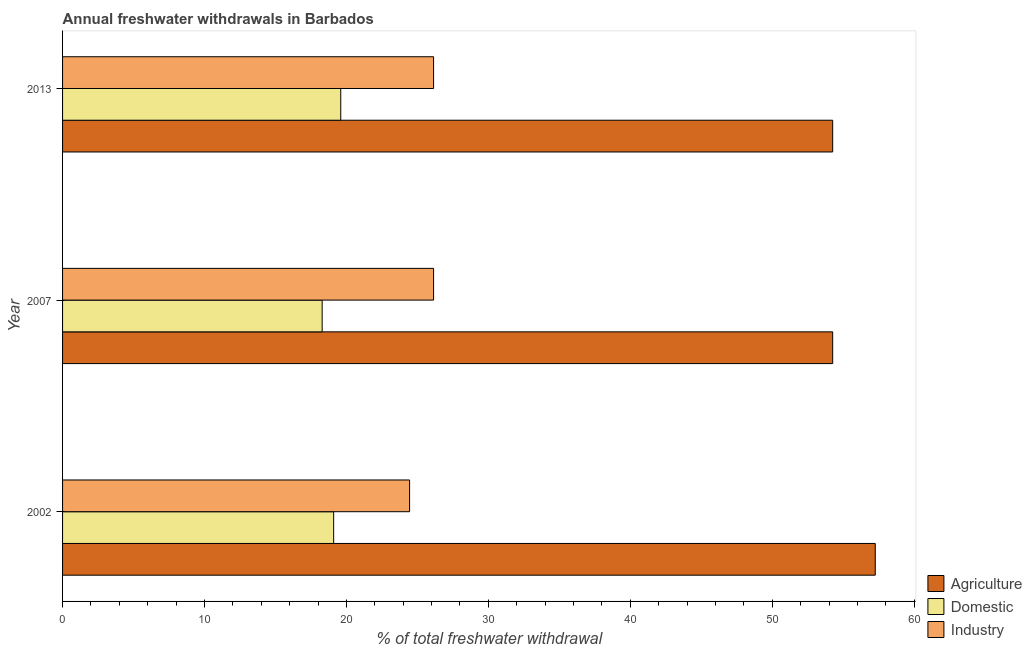How many different coloured bars are there?
Provide a short and direct response. 3. How many groups of bars are there?
Ensure brevity in your answer.  3. Are the number of bars on each tick of the Y-axis equal?
Offer a very short reply. Yes. How many bars are there on the 1st tick from the bottom?
Provide a succinct answer. 3. What is the percentage of freshwater withdrawal for industry in 2002?
Ensure brevity in your answer.  24.45. Across all years, what is the maximum percentage of freshwater withdrawal for domestic purposes?
Your answer should be compact. 19.6. Across all years, what is the minimum percentage of freshwater withdrawal for industry?
Your answer should be compact. 24.45. What is the total percentage of freshwater withdrawal for industry in the graph?
Offer a terse response. 76.73. What is the difference between the percentage of freshwater withdrawal for industry in 2002 and that in 2013?
Make the answer very short. -1.69. What is the difference between the percentage of freshwater withdrawal for domestic purposes in 2007 and the percentage of freshwater withdrawal for industry in 2013?
Provide a succinct answer. -7.85. What is the average percentage of freshwater withdrawal for domestic purposes per year?
Offer a very short reply. 19. In the year 2007, what is the difference between the percentage of freshwater withdrawal for industry and percentage of freshwater withdrawal for agriculture?
Provide a short and direct response. -28.12. In how many years, is the percentage of freshwater withdrawal for agriculture greater than 52 %?
Provide a succinct answer. 3. What is the ratio of the percentage of freshwater withdrawal for industry in 2002 to that in 2007?
Your answer should be very brief. 0.94. Is the percentage of freshwater withdrawal for domestic purposes in 2002 less than that in 2007?
Your answer should be compact. No. What is the difference between the highest and the lowest percentage of freshwater withdrawal for agriculture?
Ensure brevity in your answer.  3. What does the 1st bar from the top in 2013 represents?
Offer a terse response. Industry. What does the 1st bar from the bottom in 2007 represents?
Provide a succinct answer. Agriculture. Is it the case that in every year, the sum of the percentage of freshwater withdrawal for agriculture and percentage of freshwater withdrawal for domestic purposes is greater than the percentage of freshwater withdrawal for industry?
Your answer should be very brief. Yes. Are all the bars in the graph horizontal?
Make the answer very short. Yes. How many years are there in the graph?
Provide a succinct answer. 3. Are the values on the major ticks of X-axis written in scientific E-notation?
Provide a short and direct response. No. How many legend labels are there?
Provide a short and direct response. 3. How are the legend labels stacked?
Keep it short and to the point. Vertical. What is the title of the graph?
Your answer should be very brief. Annual freshwater withdrawals in Barbados. What is the label or title of the X-axis?
Make the answer very short. % of total freshwater withdrawal. What is the % of total freshwater withdrawal in Agriculture in 2002?
Your response must be concise. 57.26. What is the % of total freshwater withdrawal in Domestic in 2002?
Provide a short and direct response. 19.1. What is the % of total freshwater withdrawal of Industry in 2002?
Your response must be concise. 24.45. What is the % of total freshwater withdrawal of Agriculture in 2007?
Offer a terse response. 54.26. What is the % of total freshwater withdrawal in Domestic in 2007?
Provide a short and direct response. 18.29. What is the % of total freshwater withdrawal in Industry in 2007?
Offer a very short reply. 26.14. What is the % of total freshwater withdrawal of Agriculture in 2013?
Make the answer very short. 54.26. What is the % of total freshwater withdrawal in Domestic in 2013?
Your response must be concise. 19.6. What is the % of total freshwater withdrawal in Industry in 2013?
Your answer should be very brief. 26.14. Across all years, what is the maximum % of total freshwater withdrawal of Agriculture?
Ensure brevity in your answer.  57.26. Across all years, what is the maximum % of total freshwater withdrawal of Domestic?
Offer a terse response. 19.6. Across all years, what is the maximum % of total freshwater withdrawal in Industry?
Offer a terse response. 26.14. Across all years, what is the minimum % of total freshwater withdrawal in Agriculture?
Your response must be concise. 54.26. Across all years, what is the minimum % of total freshwater withdrawal in Domestic?
Provide a short and direct response. 18.29. Across all years, what is the minimum % of total freshwater withdrawal of Industry?
Your answer should be compact. 24.45. What is the total % of total freshwater withdrawal of Agriculture in the graph?
Offer a very short reply. 165.78. What is the total % of total freshwater withdrawal of Domestic in the graph?
Offer a very short reply. 56.99. What is the total % of total freshwater withdrawal in Industry in the graph?
Give a very brief answer. 76.73. What is the difference between the % of total freshwater withdrawal in Domestic in 2002 and that in 2007?
Give a very brief answer. 0.81. What is the difference between the % of total freshwater withdrawal in Industry in 2002 and that in 2007?
Offer a very short reply. -1.69. What is the difference between the % of total freshwater withdrawal in Domestic in 2002 and that in 2013?
Make the answer very short. -0.5. What is the difference between the % of total freshwater withdrawal of Industry in 2002 and that in 2013?
Keep it short and to the point. -1.69. What is the difference between the % of total freshwater withdrawal of Domestic in 2007 and that in 2013?
Your answer should be very brief. -1.31. What is the difference between the % of total freshwater withdrawal of Agriculture in 2002 and the % of total freshwater withdrawal of Domestic in 2007?
Offer a terse response. 38.97. What is the difference between the % of total freshwater withdrawal in Agriculture in 2002 and the % of total freshwater withdrawal in Industry in 2007?
Your response must be concise. 31.12. What is the difference between the % of total freshwater withdrawal in Domestic in 2002 and the % of total freshwater withdrawal in Industry in 2007?
Make the answer very short. -7.04. What is the difference between the % of total freshwater withdrawal of Agriculture in 2002 and the % of total freshwater withdrawal of Domestic in 2013?
Offer a terse response. 37.66. What is the difference between the % of total freshwater withdrawal of Agriculture in 2002 and the % of total freshwater withdrawal of Industry in 2013?
Your answer should be compact. 31.12. What is the difference between the % of total freshwater withdrawal of Domestic in 2002 and the % of total freshwater withdrawal of Industry in 2013?
Keep it short and to the point. -7.04. What is the difference between the % of total freshwater withdrawal in Agriculture in 2007 and the % of total freshwater withdrawal in Domestic in 2013?
Ensure brevity in your answer.  34.66. What is the difference between the % of total freshwater withdrawal of Agriculture in 2007 and the % of total freshwater withdrawal of Industry in 2013?
Your response must be concise. 28.12. What is the difference between the % of total freshwater withdrawal of Domestic in 2007 and the % of total freshwater withdrawal of Industry in 2013?
Ensure brevity in your answer.  -7.85. What is the average % of total freshwater withdrawal of Agriculture per year?
Ensure brevity in your answer.  55.26. What is the average % of total freshwater withdrawal in Domestic per year?
Your response must be concise. 19. What is the average % of total freshwater withdrawal in Industry per year?
Your answer should be compact. 25.58. In the year 2002, what is the difference between the % of total freshwater withdrawal in Agriculture and % of total freshwater withdrawal in Domestic?
Your answer should be very brief. 38.16. In the year 2002, what is the difference between the % of total freshwater withdrawal of Agriculture and % of total freshwater withdrawal of Industry?
Ensure brevity in your answer.  32.81. In the year 2002, what is the difference between the % of total freshwater withdrawal of Domestic and % of total freshwater withdrawal of Industry?
Give a very brief answer. -5.35. In the year 2007, what is the difference between the % of total freshwater withdrawal in Agriculture and % of total freshwater withdrawal in Domestic?
Your answer should be very brief. 35.97. In the year 2007, what is the difference between the % of total freshwater withdrawal of Agriculture and % of total freshwater withdrawal of Industry?
Your answer should be compact. 28.12. In the year 2007, what is the difference between the % of total freshwater withdrawal in Domestic and % of total freshwater withdrawal in Industry?
Offer a very short reply. -7.85. In the year 2013, what is the difference between the % of total freshwater withdrawal in Agriculture and % of total freshwater withdrawal in Domestic?
Provide a succinct answer. 34.66. In the year 2013, what is the difference between the % of total freshwater withdrawal of Agriculture and % of total freshwater withdrawal of Industry?
Your answer should be very brief. 28.12. In the year 2013, what is the difference between the % of total freshwater withdrawal of Domestic and % of total freshwater withdrawal of Industry?
Provide a short and direct response. -6.54. What is the ratio of the % of total freshwater withdrawal of Agriculture in 2002 to that in 2007?
Offer a very short reply. 1.06. What is the ratio of the % of total freshwater withdrawal in Domestic in 2002 to that in 2007?
Provide a short and direct response. 1.04. What is the ratio of the % of total freshwater withdrawal in Industry in 2002 to that in 2007?
Your response must be concise. 0.94. What is the ratio of the % of total freshwater withdrawal of Agriculture in 2002 to that in 2013?
Make the answer very short. 1.06. What is the ratio of the % of total freshwater withdrawal of Domestic in 2002 to that in 2013?
Make the answer very short. 0.97. What is the ratio of the % of total freshwater withdrawal in Industry in 2002 to that in 2013?
Your answer should be compact. 0.94. What is the ratio of the % of total freshwater withdrawal of Agriculture in 2007 to that in 2013?
Your answer should be compact. 1. What is the ratio of the % of total freshwater withdrawal of Domestic in 2007 to that in 2013?
Your answer should be very brief. 0.93. What is the difference between the highest and the second highest % of total freshwater withdrawal in Domestic?
Make the answer very short. 0.5. What is the difference between the highest and the lowest % of total freshwater withdrawal in Agriculture?
Provide a succinct answer. 3. What is the difference between the highest and the lowest % of total freshwater withdrawal of Domestic?
Keep it short and to the point. 1.31. What is the difference between the highest and the lowest % of total freshwater withdrawal of Industry?
Your answer should be compact. 1.69. 